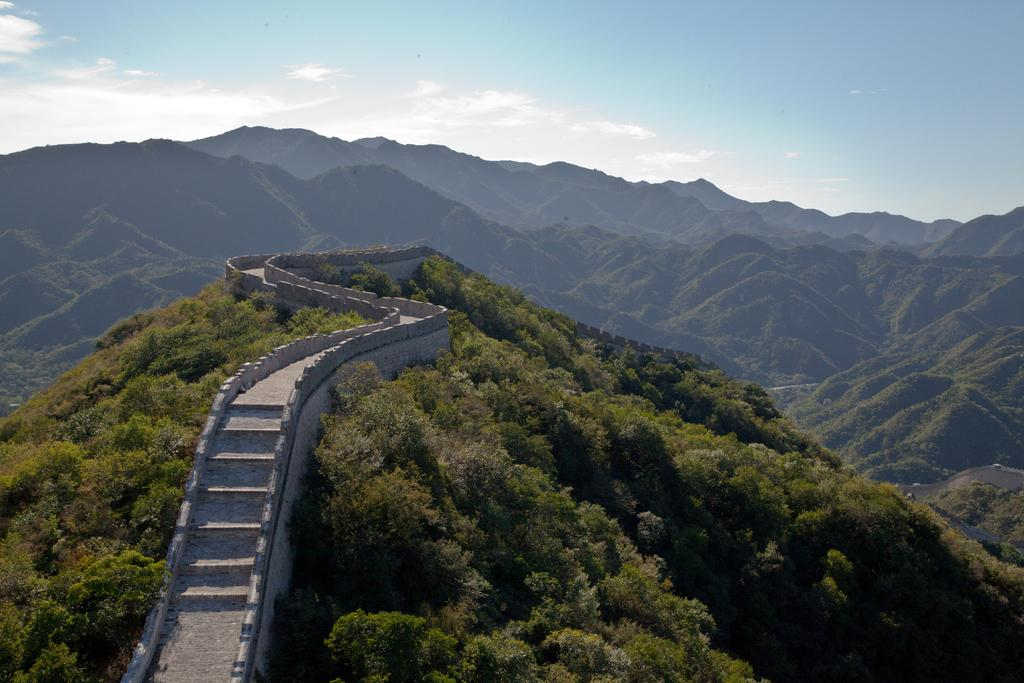What type of path is visible in the image? There is a walkway in the image. Are there any elevation changes in the walkway? Yes, there are stairs in the image. What is the walkway adjacent to? There is a wall in the image. What type of vegetation can be seen in the image? There are trees in the image. What can be seen in the distance in the image? The background of the image includes hills. What is visible above the walkway and trees? The sky is visible in the background of the image. What type of business is being conducted on the ground in the image? There is no business or ground present in the image; it features a walkway, stairs, wall, trees, hills, and sky. What type of whip can be seen in the image? There is no whip present in the image. 